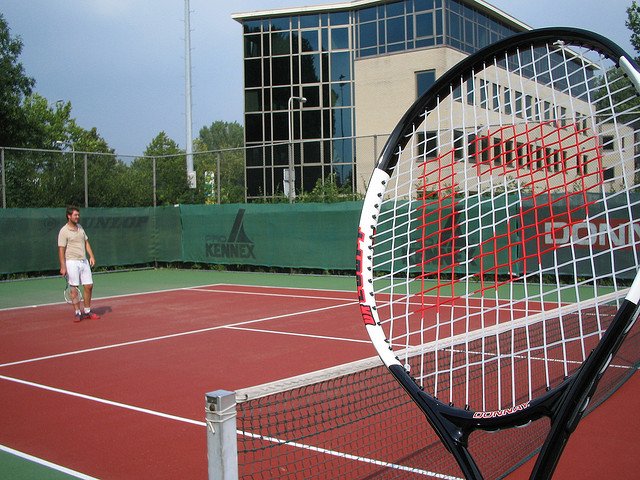Who plays this sport?
A. marian hossa
B. serena williams
C. bo jackson
D. pele
Answer with the option's letter from the given choices directly. B 